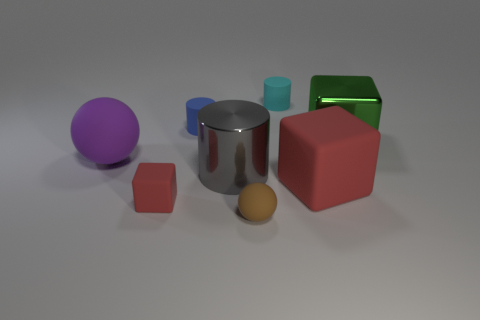Do the big red object and the small cylinder behind the blue thing have the same material?
Provide a succinct answer. Yes. What number of things are either spheres that are right of the big purple object or small green metallic things?
Provide a succinct answer. 1. There is a small rubber object that is both behind the big red cube and left of the cyan matte cylinder; what shape is it?
Your answer should be very brief. Cylinder. What is the size of the purple object that is made of the same material as the small blue cylinder?
Your answer should be very brief. Large. How many objects are big objects behind the big purple thing or tiny cylinders that are to the left of the cyan matte thing?
Offer a terse response. 2. Do the metallic thing to the right of the cyan object and the large purple ball have the same size?
Ensure brevity in your answer.  Yes. What color is the tiny rubber cylinder that is on the left side of the small cyan object?
Provide a succinct answer. Blue. What color is the other rubber thing that is the same shape as the small brown thing?
Provide a short and direct response. Purple. There is a rubber cylinder to the right of the rubber ball that is in front of the small cube; how many rubber cylinders are left of it?
Give a very brief answer. 1. Are there fewer big red objects behind the large gray metal cylinder than small brown rubber balls?
Provide a succinct answer. Yes. 